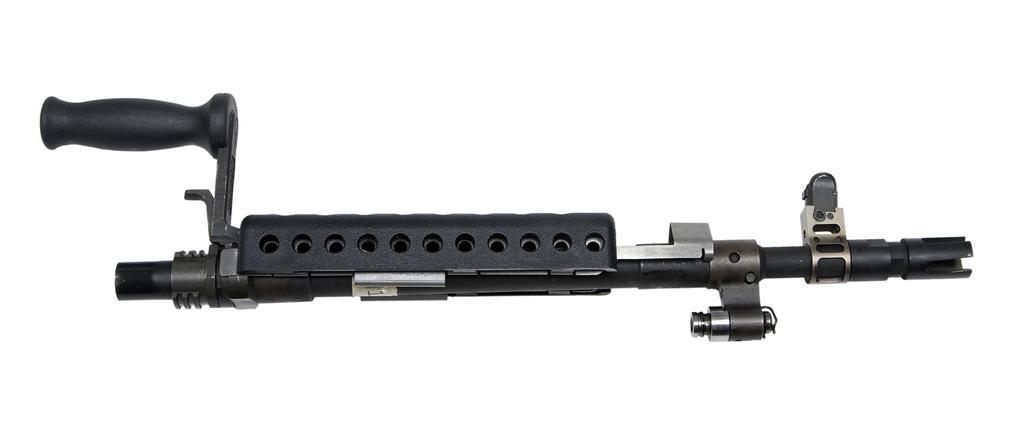Describe this image in one or two sentences. In this image there is a gun, background is white. 